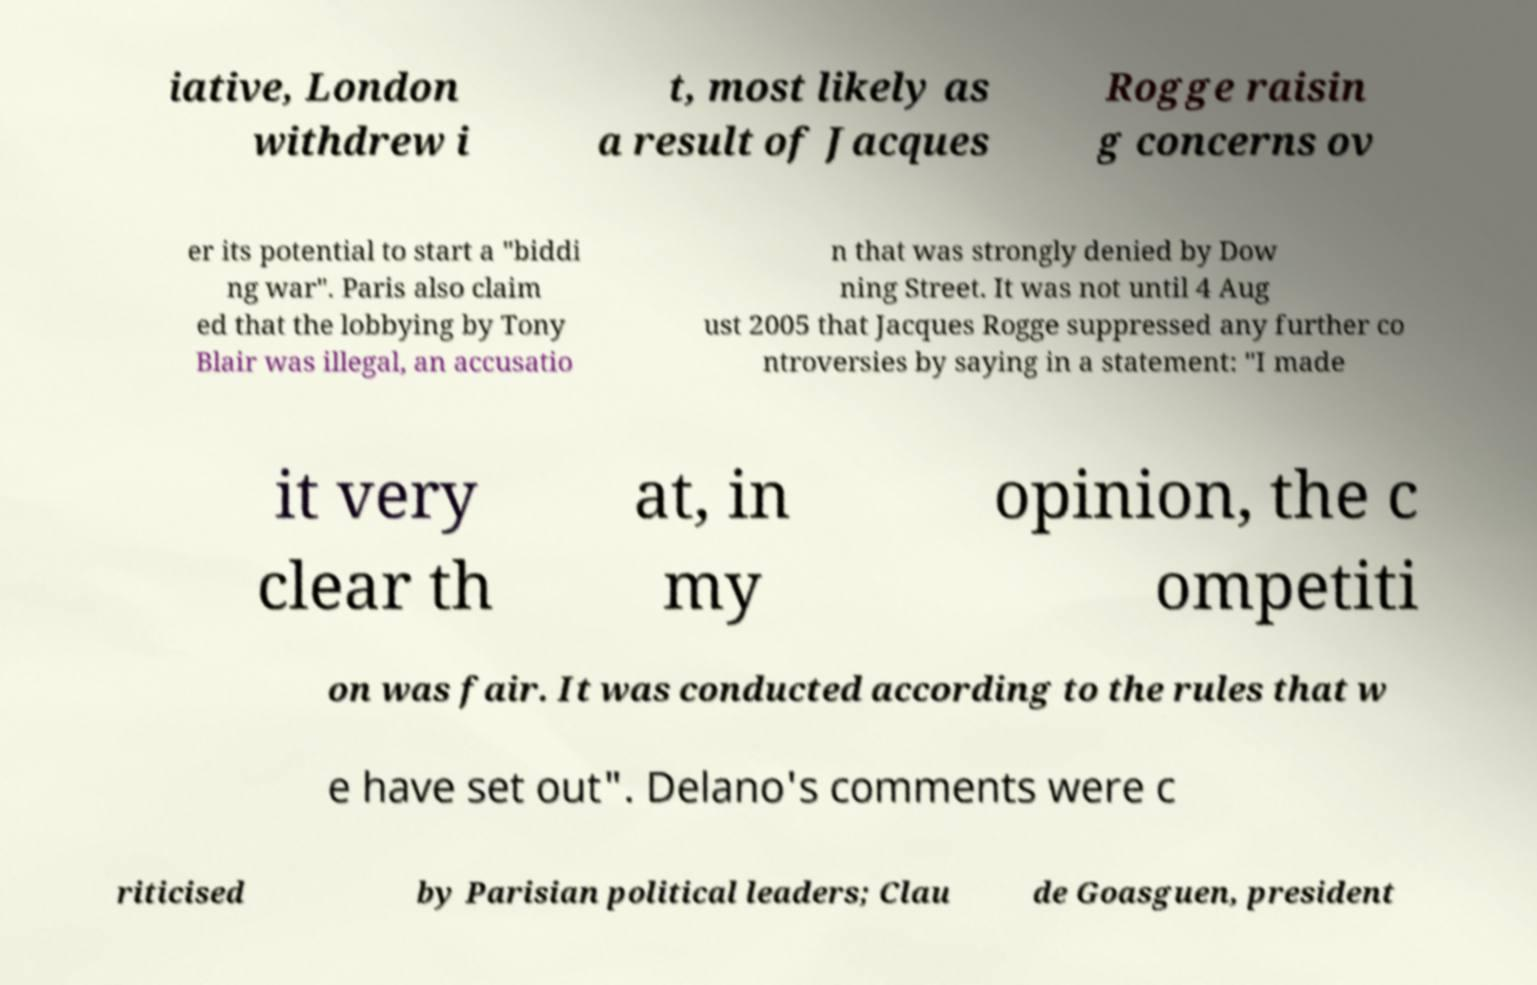Please identify and transcribe the text found in this image. iative, London withdrew i t, most likely as a result of Jacques Rogge raisin g concerns ov er its potential to start a "biddi ng war". Paris also claim ed that the lobbying by Tony Blair was illegal, an accusatio n that was strongly denied by Dow ning Street. It was not until 4 Aug ust 2005 that Jacques Rogge suppressed any further co ntroversies by saying in a statement: "I made it very clear th at, in my opinion, the c ompetiti on was fair. It was conducted according to the rules that w e have set out". Delano's comments were c riticised by Parisian political leaders; Clau de Goasguen, president 